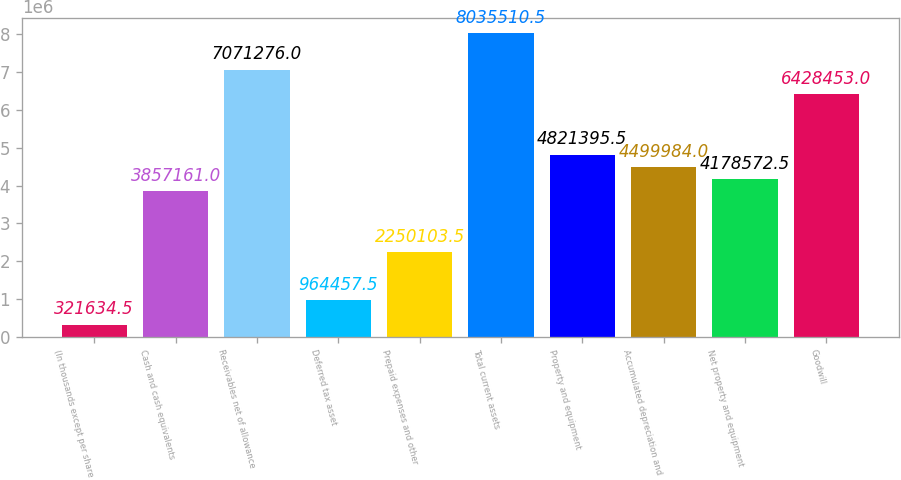Convert chart. <chart><loc_0><loc_0><loc_500><loc_500><bar_chart><fcel>(In thousands except per share<fcel>Cash and cash equivalents<fcel>Receivables net of allowance<fcel>Deferred tax asset<fcel>Prepaid expenses and other<fcel>Total current assets<fcel>Property and equipment<fcel>Accumulated depreciation and<fcel>Net property and equipment<fcel>Goodwill<nl><fcel>321634<fcel>3.85716e+06<fcel>7.07128e+06<fcel>964458<fcel>2.2501e+06<fcel>8.03551e+06<fcel>4.8214e+06<fcel>4.49998e+06<fcel>4.17857e+06<fcel>6.42845e+06<nl></chart> 